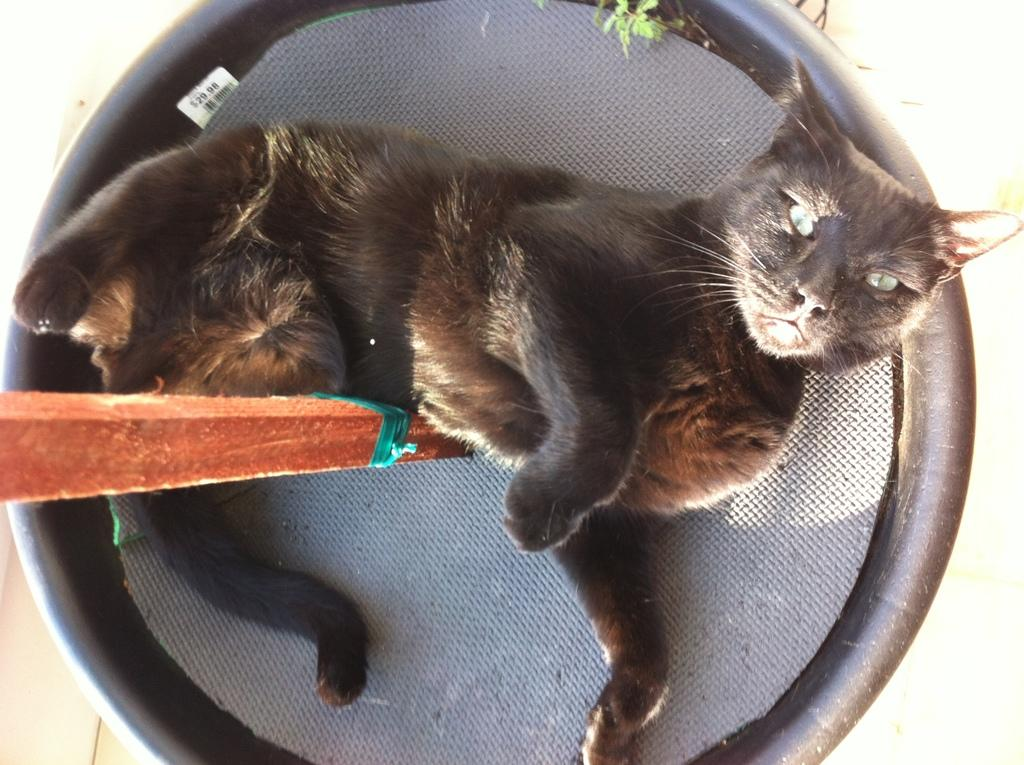What type of animal is in the image? There is a black color cat in the image. What is the cat sitting on? The cat is on a black color object. What other object can be seen in the image? There is a brown color stick in the image. Is the watch visible on the cat's paw in the image? There is no watch present in the image; it only features a black color cat, a black color object, and a brown color stick. 